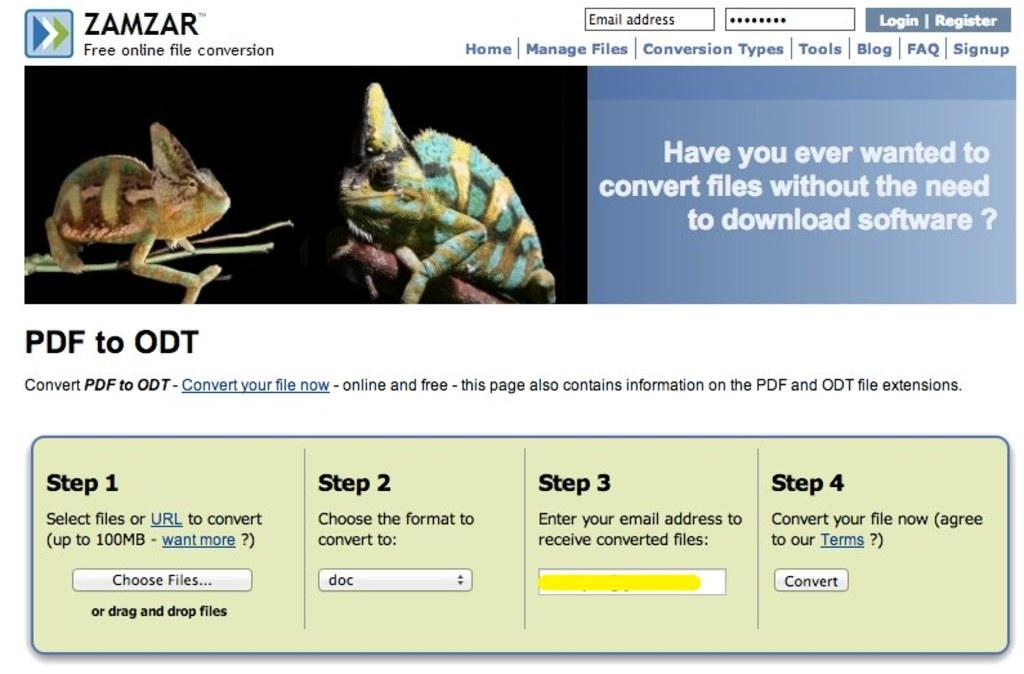What is the source of the image? The image appears to be taken from a website. What type of content is present in the image? There are two animated images and registration portals in the image. What other information elements can be seen in the image? There are other different information elements in the image. How much profit does the cheese-making company make in the image? There is no mention of a cheese-making company or profit in the image. How many planes are visible in the image? There are no planes visible in the image. 